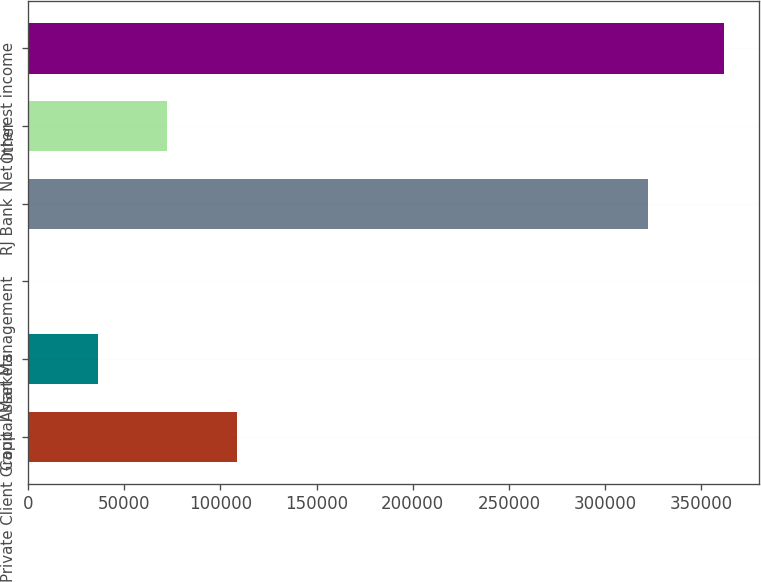Convert chart. <chart><loc_0><loc_0><loc_500><loc_500><bar_chart><fcel>Private Client Group<fcel>Capital Markets<fcel>Asset Management<fcel>RJ Bank<fcel>Other<fcel>Net interest income<nl><fcel>108579<fcel>36204.2<fcel>17<fcel>322024<fcel>72391.4<fcel>361889<nl></chart> 